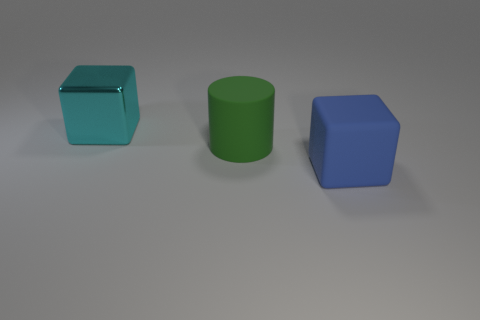Subtract all blue cylinders. Subtract all red cubes. How many cylinders are left? 1 Add 1 cylinders. How many objects exist? 4 Subtract all cylinders. How many objects are left? 2 Add 1 cyan shiny blocks. How many cyan shiny blocks exist? 2 Subtract 0 green blocks. How many objects are left? 3 Subtract all rubber things. Subtract all small cyan cubes. How many objects are left? 1 Add 3 green things. How many green things are left? 4 